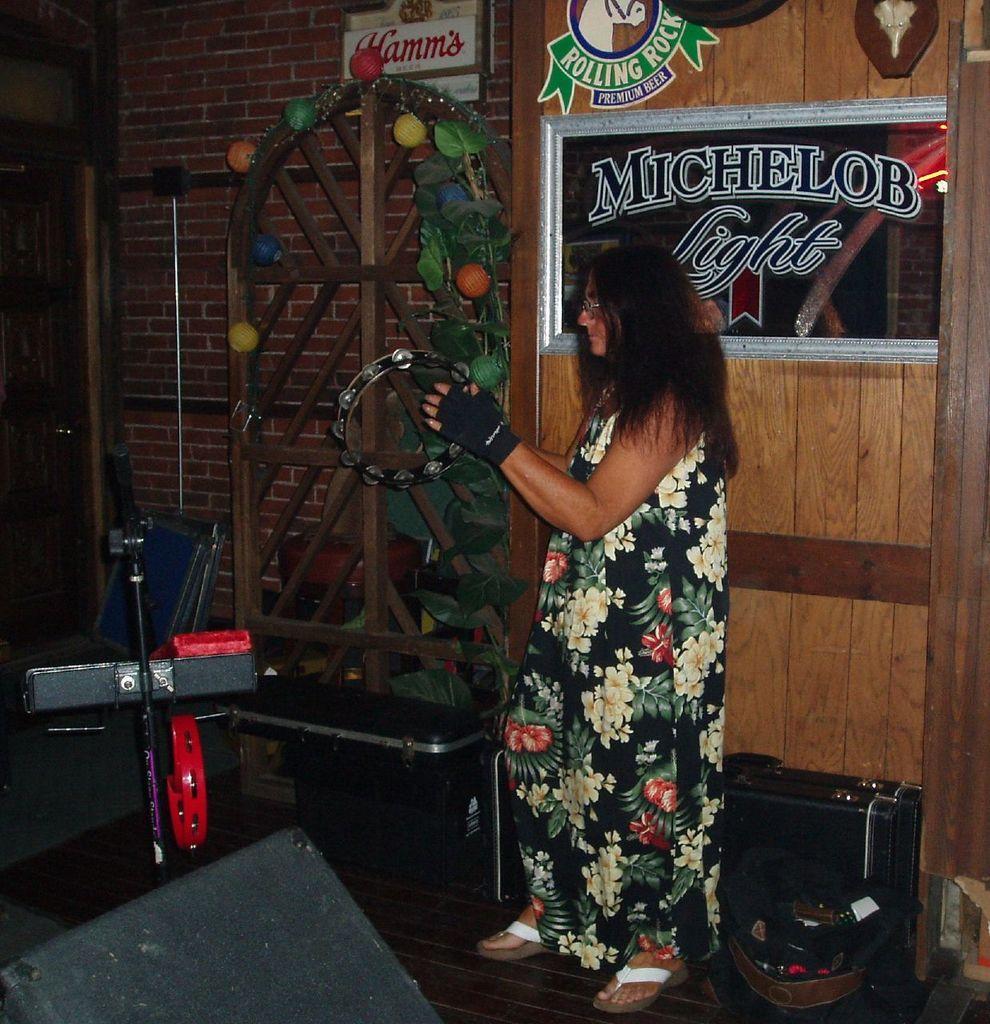Can you describe this image briefly? In the image we can see there is a woman standing and she is holding a musical instrument in her hand. There are other musical instruments on the ground and behind there is a wall made up of red bricks. There are decorative items kept on the wall. 